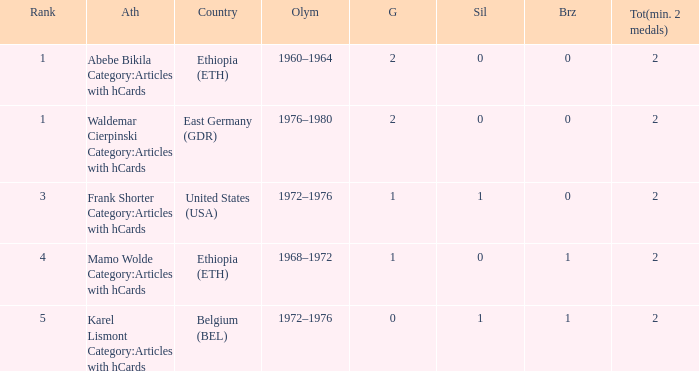Can you parse all the data within this table? {'header': ['Rank', 'Ath', 'Country', 'Olym', 'G', 'Sil', 'Brz', 'Tot(min. 2 medals)'], 'rows': [['1', 'Abebe Bikila Category:Articles with hCards', 'Ethiopia (ETH)', '1960–1964', '2', '0', '0', '2'], ['1', 'Waldemar Cierpinski Category:Articles with hCards', 'East Germany (GDR)', '1976–1980', '2', '0', '0', '2'], ['3', 'Frank Shorter Category:Articles with hCards', 'United States (USA)', '1972–1976', '1', '1', '0', '2'], ['4', 'Mamo Wolde Category:Articles with hCards', 'Ethiopia (ETH)', '1968–1972', '1', '0', '1', '2'], ['5', 'Karel Lismont Category:Articles with hCards', 'Belgium (BEL)', '1972–1976', '0', '1', '1', '2']]} What is the least amount of total medals won? 2.0. 